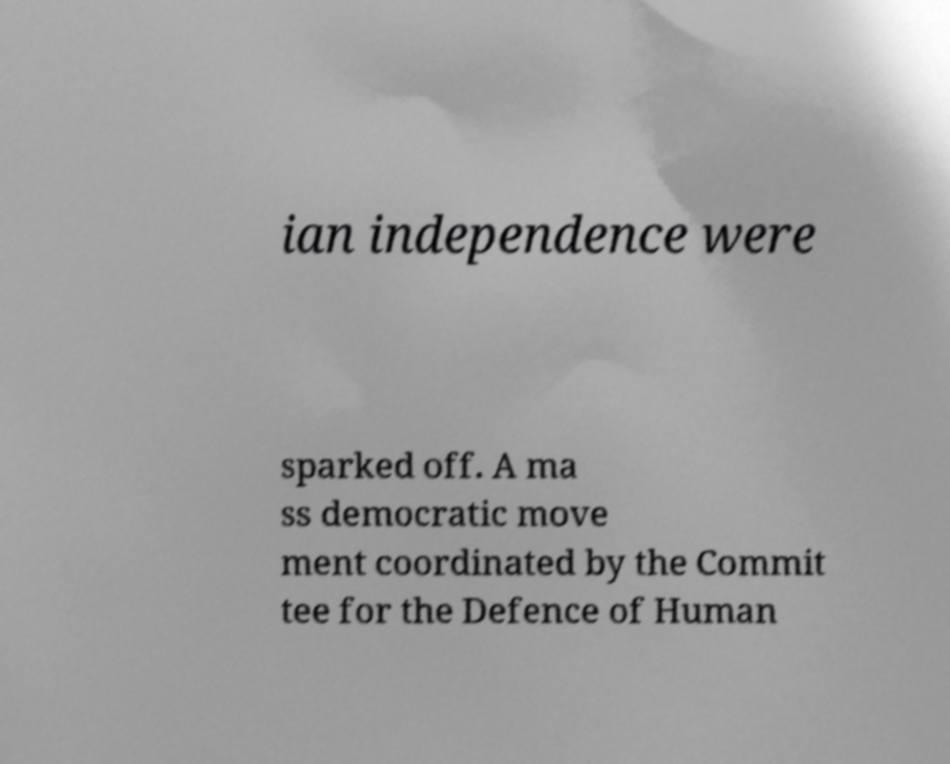Could you extract and type out the text from this image? ian independence were sparked off. A ma ss democratic move ment coordinated by the Commit tee for the Defence of Human 